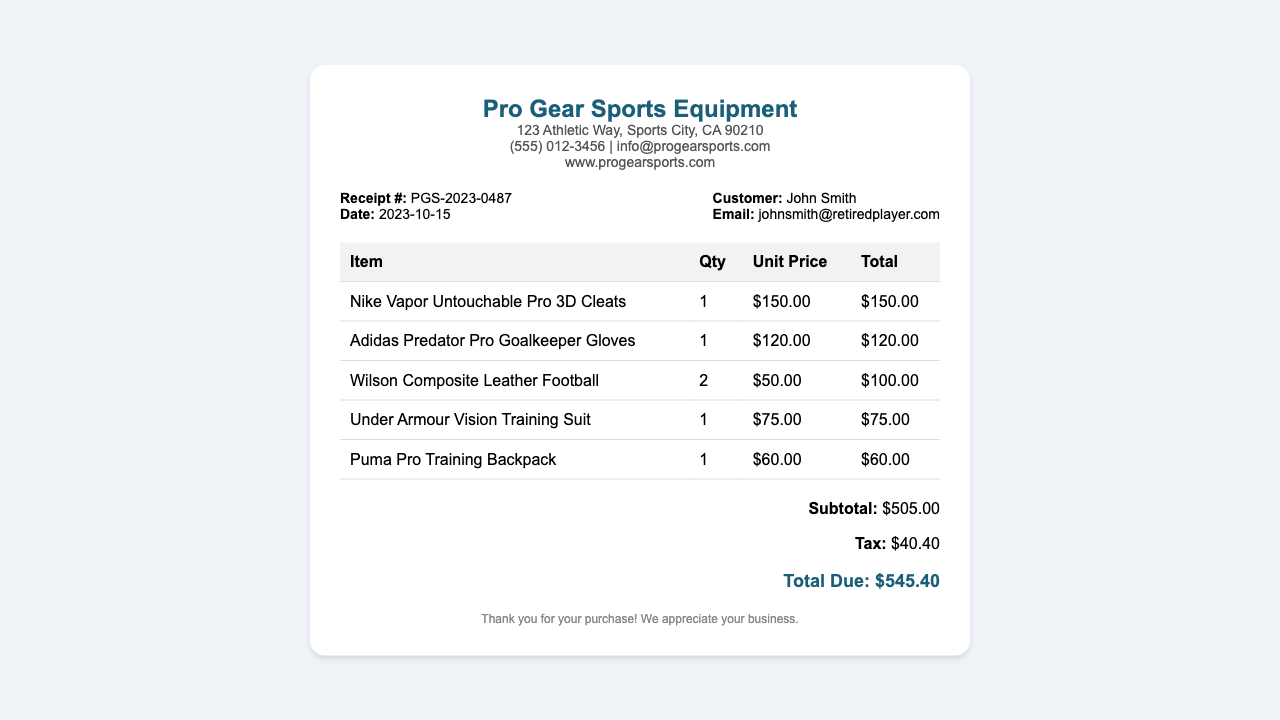What is the receipt number? The receipt number is explicitly stated in the document as PGS-2023-0487.
Answer: PGS-2023-0487 What is the purchase date? The purchase date can be found in the document, listed as 2023-10-15.
Answer: 2023-10-15 Who is the customer? The customer's name is mentioned in the document as John Smith.
Answer: John Smith How much did the Nike Vapor Untouchable Pro 3D Cleats cost? The cost of the Nike Vapor Untouchable Pro 3D Cleats is detailed in the document as $150.00.
Answer: $150.00 What is the subtotal amount? The subtotal amount is displayed in the document as $505.00 before tax.
Answer: $505.00 What is the total due amount? The total due amount, which includes tax, is specified in the document as $545.40.
Answer: $545.40 How many Adidas Predator Pro Goalkeeper Gloves were purchased? The document states that 1 pair of Adidas Predator Pro Goalkeeper Gloves was purchased.
Answer: 1 What is the vendor's email address? The vendor's email address is provided in the document: info@progearsports.com.
Answer: info@progearsports.com What type of document is this? The structure and content indicate this document is a receipt for equipment purchase.
Answer: Receipt 